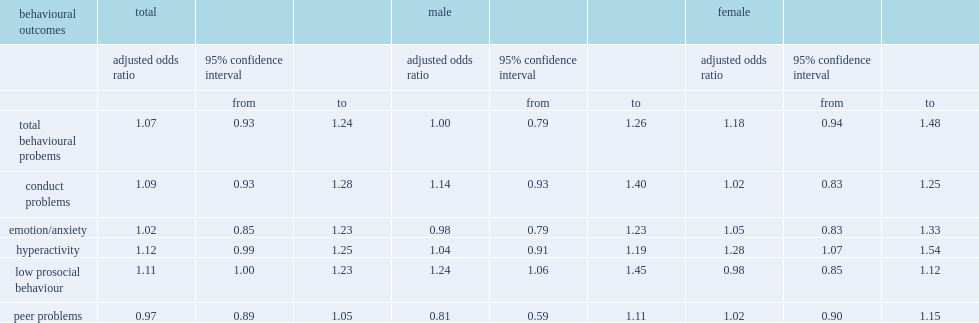List the behavioural outcomes in the table. Total behavioural probems conduct problems emotion/anxiety hyperactivity low prosocial behaviour peer problems. What were the greater odds of hyperactivity of girls and the greater odds of low prosocial behaviour of boys respectively? 0.28 0.24. 